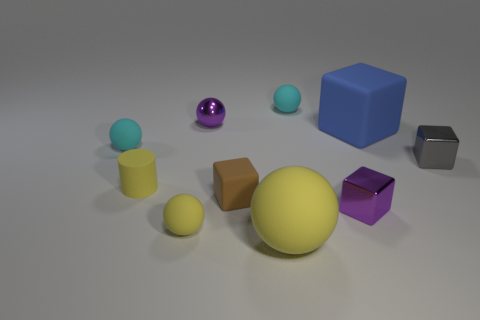Subtract all purple metal balls. How many balls are left? 4 Subtract all purple spheres. How many spheres are left? 4 Subtract all green balls. Subtract all red cylinders. How many balls are left? 5 Subtract all cylinders. How many objects are left? 9 Subtract all rubber cylinders. Subtract all small cyan things. How many objects are left? 7 Add 8 metallic spheres. How many metallic spheres are left? 9 Add 6 tiny gray blocks. How many tiny gray blocks exist? 7 Subtract 1 gray cubes. How many objects are left? 9 